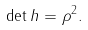Convert formula to latex. <formula><loc_0><loc_0><loc_500><loc_500>\det { h } = \rho ^ { 2 } .</formula> 